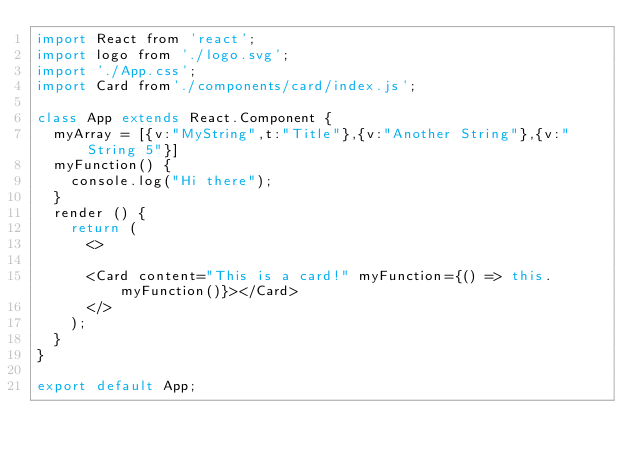<code> <loc_0><loc_0><loc_500><loc_500><_JavaScript_>import React from 'react';
import logo from './logo.svg';
import './App.css';
import Card from'./components/card/index.js';

class App extends React.Component {
  myArray = [{v:"MyString",t:"Title"},{v:"Another String"},{v:"String 5"}]
  myFunction() {
    console.log("Hi there");
  }
  render () {
    return (
      <>
 
      <Card content="This is a card!" myFunction={() => this.myFunction()}></Card>
      </>
    );
  }
}

export default App;
</code> 